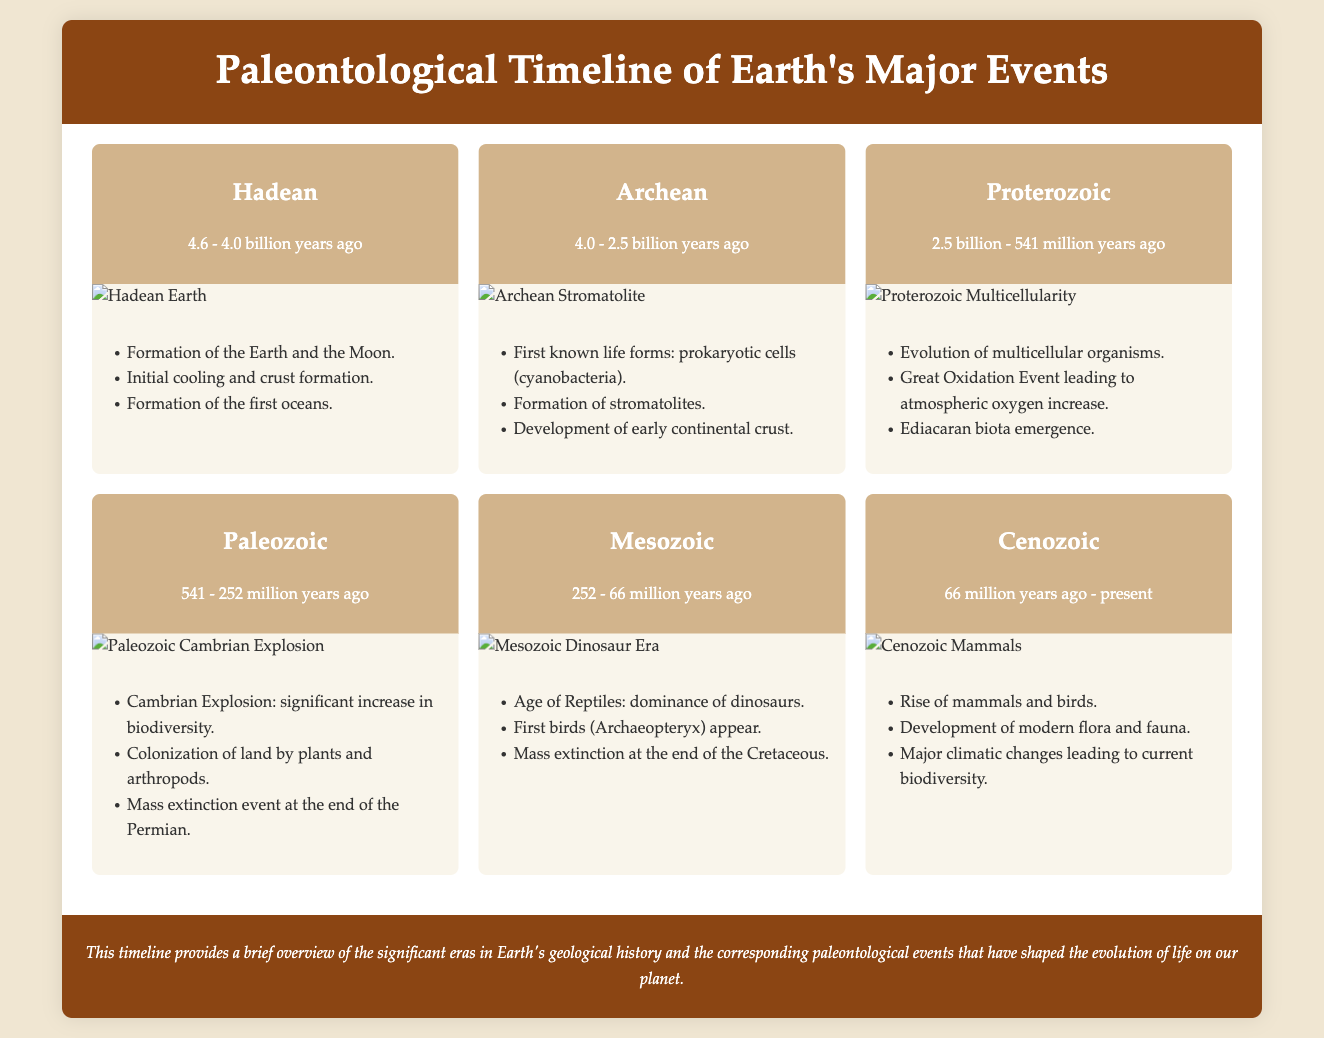What is the time span of the Hadean era? The Hadean era lasts from 4.6 to 4.0 billion years ago as indicated in the document.
Answer: 4.6 - 4.0 billion years ago What life forms emerged during the Archean era? The document mentions first known life forms being prokaryotic cells (cyanobacteria) during the Archean era.
Answer: Prokaryotic cells (cyanobacteria) What significant event occurred at the end of the Paleozoic era? The document states that there was a mass extinction event at the end of the Permian, which is part of the Paleozoic era.
Answer: Mass extinction event How long did the Mesozoic era last? The Mesozoic era is defined in the document as lasting from 252 to 66 million years ago, which can be calculated for its duration.
Answer: 186 million years Which organism appeared during the Mesozoic era? According to the document, Archaeopteryx is cited as the first bird appearing during the Mesozoic era.
Answer: Archaeopteryx What event is referred to as the Cambrian Explosion? The Cambrian Explosion is described in the document as a significant increase in biodiversity during the Paleozoic era.
Answer: Significant increase in biodiversity What is mentioned as the driving force for the Great Oxidation Event? The document highlights the Great Oxidation Event leading to an increase in atmospheric oxygen during the Proterozoic era.
Answer: Atmospheric oxygen increase When did the Cenozoic era begin? The Cenozoic era began 66 million years ago, as stated in the document.
Answer: 66 million years ago 